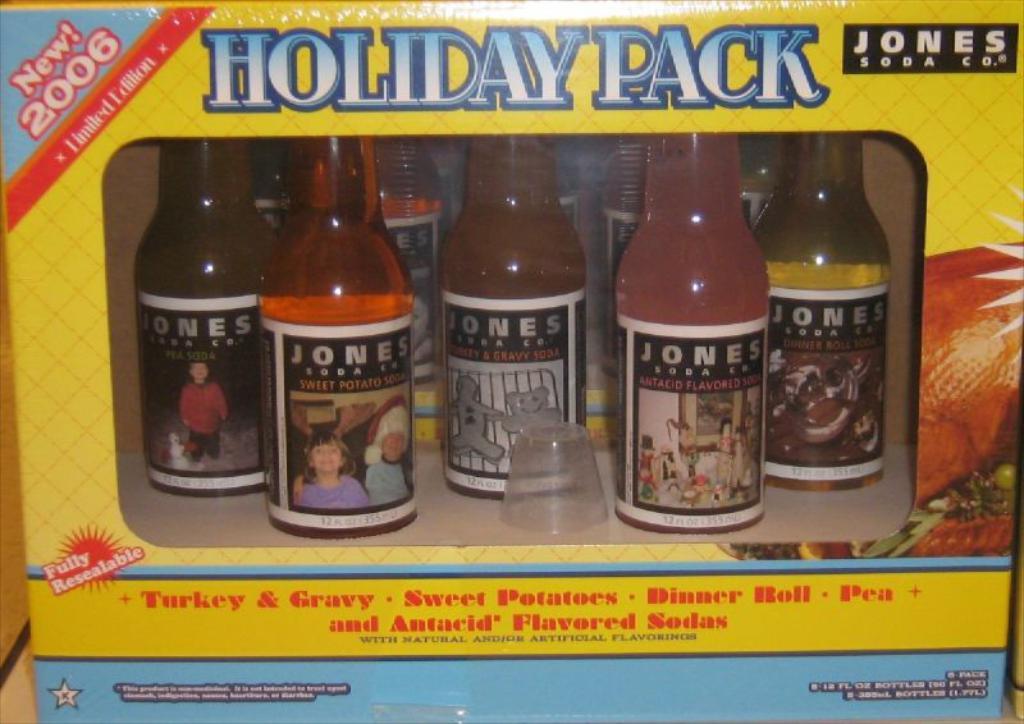What kind of special pack is it?
Provide a succinct answer. Holiday pack. What year are these?
Keep it short and to the point. 2006. 